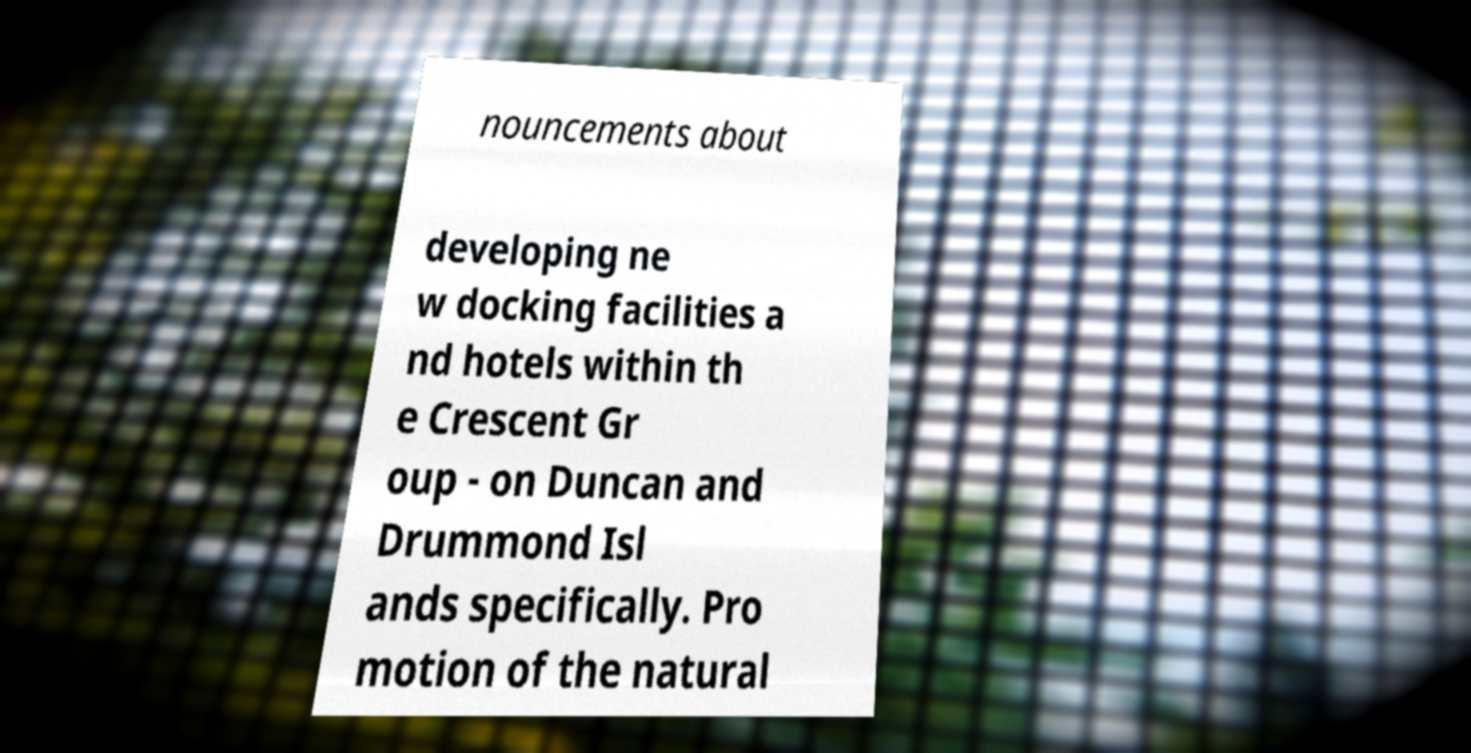For documentation purposes, I need the text within this image transcribed. Could you provide that? nouncements about developing ne w docking facilities a nd hotels within th e Crescent Gr oup - on Duncan and Drummond Isl ands specifically. Pro motion of the natural 